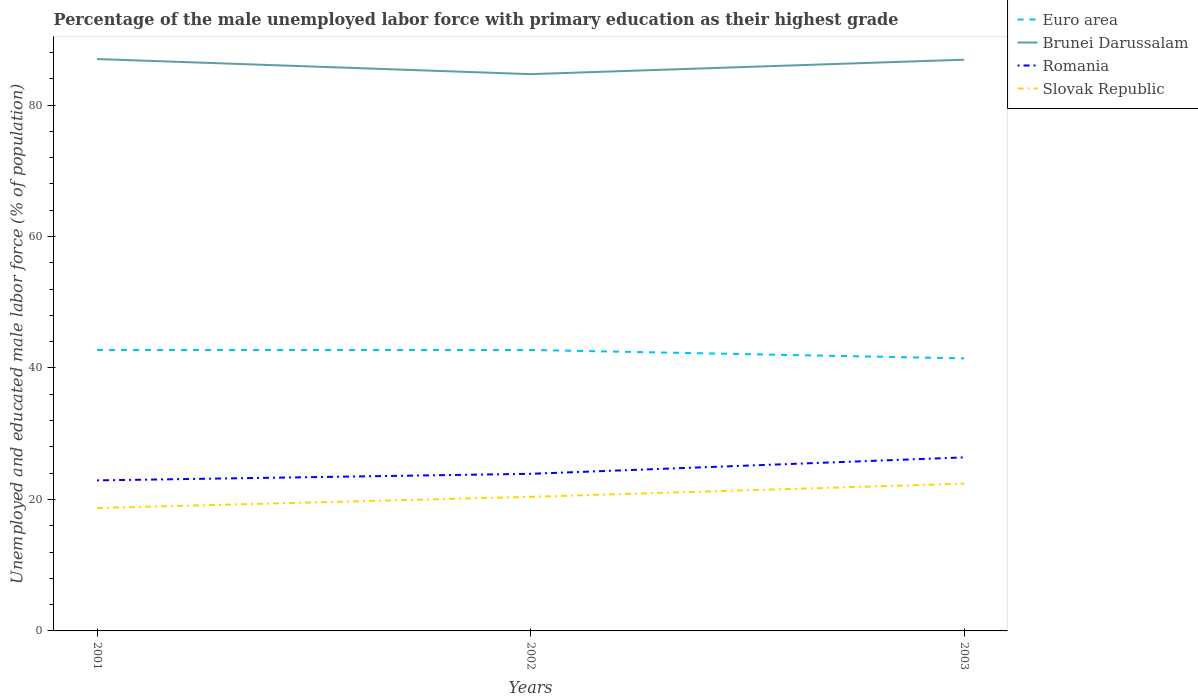Does the line corresponding to Slovak Republic intersect with the line corresponding to Euro area?
Provide a short and direct response. No. Is the number of lines equal to the number of legend labels?
Ensure brevity in your answer.  Yes. Across all years, what is the maximum percentage of the unemployed male labor force with primary education in Brunei Darussalam?
Your answer should be very brief. 84.7. How many lines are there?
Your answer should be very brief. 4. How many years are there in the graph?
Offer a very short reply. 3. What is the difference between two consecutive major ticks on the Y-axis?
Provide a succinct answer. 20. Where does the legend appear in the graph?
Offer a very short reply. Top right. How are the legend labels stacked?
Ensure brevity in your answer.  Vertical. What is the title of the graph?
Ensure brevity in your answer.  Percentage of the male unemployed labor force with primary education as their highest grade. What is the label or title of the Y-axis?
Provide a short and direct response. Unemployed and educated male labor force (% of population). What is the Unemployed and educated male labor force (% of population) in Euro area in 2001?
Offer a very short reply. 42.74. What is the Unemployed and educated male labor force (% of population) in Romania in 2001?
Offer a terse response. 22.9. What is the Unemployed and educated male labor force (% of population) of Slovak Republic in 2001?
Ensure brevity in your answer.  18.7. What is the Unemployed and educated male labor force (% of population) in Euro area in 2002?
Provide a short and direct response. 42.74. What is the Unemployed and educated male labor force (% of population) in Brunei Darussalam in 2002?
Your answer should be very brief. 84.7. What is the Unemployed and educated male labor force (% of population) in Romania in 2002?
Keep it short and to the point. 23.9. What is the Unemployed and educated male labor force (% of population) of Slovak Republic in 2002?
Your answer should be very brief. 20.4. What is the Unemployed and educated male labor force (% of population) of Euro area in 2003?
Your answer should be very brief. 41.46. What is the Unemployed and educated male labor force (% of population) of Brunei Darussalam in 2003?
Make the answer very short. 86.9. What is the Unemployed and educated male labor force (% of population) of Romania in 2003?
Offer a terse response. 26.4. What is the Unemployed and educated male labor force (% of population) in Slovak Republic in 2003?
Your response must be concise. 22.4. Across all years, what is the maximum Unemployed and educated male labor force (% of population) in Euro area?
Give a very brief answer. 42.74. Across all years, what is the maximum Unemployed and educated male labor force (% of population) in Romania?
Offer a terse response. 26.4. Across all years, what is the maximum Unemployed and educated male labor force (% of population) in Slovak Republic?
Your response must be concise. 22.4. Across all years, what is the minimum Unemployed and educated male labor force (% of population) in Euro area?
Ensure brevity in your answer.  41.46. Across all years, what is the minimum Unemployed and educated male labor force (% of population) in Brunei Darussalam?
Provide a succinct answer. 84.7. Across all years, what is the minimum Unemployed and educated male labor force (% of population) in Romania?
Offer a very short reply. 22.9. Across all years, what is the minimum Unemployed and educated male labor force (% of population) of Slovak Republic?
Make the answer very short. 18.7. What is the total Unemployed and educated male labor force (% of population) in Euro area in the graph?
Keep it short and to the point. 126.95. What is the total Unemployed and educated male labor force (% of population) of Brunei Darussalam in the graph?
Your response must be concise. 258.6. What is the total Unemployed and educated male labor force (% of population) of Romania in the graph?
Your answer should be very brief. 73.2. What is the total Unemployed and educated male labor force (% of population) in Slovak Republic in the graph?
Your answer should be compact. 61.5. What is the difference between the Unemployed and educated male labor force (% of population) in Euro area in 2001 and that in 2002?
Provide a succinct answer. 0. What is the difference between the Unemployed and educated male labor force (% of population) in Romania in 2001 and that in 2002?
Provide a short and direct response. -1. What is the difference between the Unemployed and educated male labor force (% of population) of Euro area in 2001 and that in 2003?
Your answer should be very brief. 1.28. What is the difference between the Unemployed and educated male labor force (% of population) in Slovak Republic in 2001 and that in 2003?
Provide a succinct answer. -3.7. What is the difference between the Unemployed and educated male labor force (% of population) of Euro area in 2002 and that in 2003?
Ensure brevity in your answer.  1.28. What is the difference between the Unemployed and educated male labor force (% of population) in Brunei Darussalam in 2002 and that in 2003?
Your answer should be compact. -2.2. What is the difference between the Unemployed and educated male labor force (% of population) in Romania in 2002 and that in 2003?
Provide a short and direct response. -2.5. What is the difference between the Unemployed and educated male labor force (% of population) of Slovak Republic in 2002 and that in 2003?
Your answer should be compact. -2. What is the difference between the Unemployed and educated male labor force (% of population) in Euro area in 2001 and the Unemployed and educated male labor force (% of population) in Brunei Darussalam in 2002?
Offer a terse response. -41.96. What is the difference between the Unemployed and educated male labor force (% of population) in Euro area in 2001 and the Unemployed and educated male labor force (% of population) in Romania in 2002?
Offer a very short reply. 18.84. What is the difference between the Unemployed and educated male labor force (% of population) of Euro area in 2001 and the Unemployed and educated male labor force (% of population) of Slovak Republic in 2002?
Give a very brief answer. 22.34. What is the difference between the Unemployed and educated male labor force (% of population) in Brunei Darussalam in 2001 and the Unemployed and educated male labor force (% of population) in Romania in 2002?
Make the answer very short. 63.1. What is the difference between the Unemployed and educated male labor force (% of population) of Brunei Darussalam in 2001 and the Unemployed and educated male labor force (% of population) of Slovak Republic in 2002?
Make the answer very short. 66.6. What is the difference between the Unemployed and educated male labor force (% of population) in Euro area in 2001 and the Unemployed and educated male labor force (% of population) in Brunei Darussalam in 2003?
Make the answer very short. -44.16. What is the difference between the Unemployed and educated male labor force (% of population) of Euro area in 2001 and the Unemployed and educated male labor force (% of population) of Romania in 2003?
Give a very brief answer. 16.34. What is the difference between the Unemployed and educated male labor force (% of population) in Euro area in 2001 and the Unemployed and educated male labor force (% of population) in Slovak Republic in 2003?
Give a very brief answer. 20.34. What is the difference between the Unemployed and educated male labor force (% of population) in Brunei Darussalam in 2001 and the Unemployed and educated male labor force (% of population) in Romania in 2003?
Make the answer very short. 60.6. What is the difference between the Unemployed and educated male labor force (% of population) of Brunei Darussalam in 2001 and the Unemployed and educated male labor force (% of population) of Slovak Republic in 2003?
Your answer should be compact. 64.6. What is the difference between the Unemployed and educated male labor force (% of population) of Euro area in 2002 and the Unemployed and educated male labor force (% of population) of Brunei Darussalam in 2003?
Offer a terse response. -44.16. What is the difference between the Unemployed and educated male labor force (% of population) in Euro area in 2002 and the Unemployed and educated male labor force (% of population) in Romania in 2003?
Offer a very short reply. 16.34. What is the difference between the Unemployed and educated male labor force (% of population) in Euro area in 2002 and the Unemployed and educated male labor force (% of population) in Slovak Republic in 2003?
Ensure brevity in your answer.  20.34. What is the difference between the Unemployed and educated male labor force (% of population) in Brunei Darussalam in 2002 and the Unemployed and educated male labor force (% of population) in Romania in 2003?
Ensure brevity in your answer.  58.3. What is the difference between the Unemployed and educated male labor force (% of population) of Brunei Darussalam in 2002 and the Unemployed and educated male labor force (% of population) of Slovak Republic in 2003?
Offer a very short reply. 62.3. What is the average Unemployed and educated male labor force (% of population) of Euro area per year?
Keep it short and to the point. 42.32. What is the average Unemployed and educated male labor force (% of population) of Brunei Darussalam per year?
Provide a succinct answer. 86.2. What is the average Unemployed and educated male labor force (% of population) in Romania per year?
Your answer should be compact. 24.4. In the year 2001, what is the difference between the Unemployed and educated male labor force (% of population) of Euro area and Unemployed and educated male labor force (% of population) of Brunei Darussalam?
Keep it short and to the point. -44.26. In the year 2001, what is the difference between the Unemployed and educated male labor force (% of population) in Euro area and Unemployed and educated male labor force (% of population) in Romania?
Your response must be concise. 19.84. In the year 2001, what is the difference between the Unemployed and educated male labor force (% of population) of Euro area and Unemployed and educated male labor force (% of population) of Slovak Republic?
Keep it short and to the point. 24.04. In the year 2001, what is the difference between the Unemployed and educated male labor force (% of population) in Brunei Darussalam and Unemployed and educated male labor force (% of population) in Romania?
Offer a terse response. 64.1. In the year 2001, what is the difference between the Unemployed and educated male labor force (% of population) in Brunei Darussalam and Unemployed and educated male labor force (% of population) in Slovak Republic?
Make the answer very short. 68.3. In the year 2002, what is the difference between the Unemployed and educated male labor force (% of population) of Euro area and Unemployed and educated male labor force (% of population) of Brunei Darussalam?
Your response must be concise. -41.96. In the year 2002, what is the difference between the Unemployed and educated male labor force (% of population) of Euro area and Unemployed and educated male labor force (% of population) of Romania?
Offer a very short reply. 18.84. In the year 2002, what is the difference between the Unemployed and educated male labor force (% of population) of Euro area and Unemployed and educated male labor force (% of population) of Slovak Republic?
Offer a very short reply. 22.34. In the year 2002, what is the difference between the Unemployed and educated male labor force (% of population) in Brunei Darussalam and Unemployed and educated male labor force (% of population) in Romania?
Give a very brief answer. 60.8. In the year 2002, what is the difference between the Unemployed and educated male labor force (% of population) of Brunei Darussalam and Unemployed and educated male labor force (% of population) of Slovak Republic?
Offer a terse response. 64.3. In the year 2002, what is the difference between the Unemployed and educated male labor force (% of population) of Romania and Unemployed and educated male labor force (% of population) of Slovak Republic?
Provide a succinct answer. 3.5. In the year 2003, what is the difference between the Unemployed and educated male labor force (% of population) of Euro area and Unemployed and educated male labor force (% of population) of Brunei Darussalam?
Ensure brevity in your answer.  -45.44. In the year 2003, what is the difference between the Unemployed and educated male labor force (% of population) in Euro area and Unemployed and educated male labor force (% of population) in Romania?
Your response must be concise. 15.06. In the year 2003, what is the difference between the Unemployed and educated male labor force (% of population) of Euro area and Unemployed and educated male labor force (% of population) of Slovak Republic?
Ensure brevity in your answer.  19.06. In the year 2003, what is the difference between the Unemployed and educated male labor force (% of population) of Brunei Darussalam and Unemployed and educated male labor force (% of population) of Romania?
Your answer should be compact. 60.5. In the year 2003, what is the difference between the Unemployed and educated male labor force (% of population) in Brunei Darussalam and Unemployed and educated male labor force (% of population) in Slovak Republic?
Your response must be concise. 64.5. In the year 2003, what is the difference between the Unemployed and educated male labor force (% of population) in Romania and Unemployed and educated male labor force (% of population) in Slovak Republic?
Make the answer very short. 4. What is the ratio of the Unemployed and educated male labor force (% of population) in Euro area in 2001 to that in 2002?
Ensure brevity in your answer.  1. What is the ratio of the Unemployed and educated male labor force (% of population) in Brunei Darussalam in 2001 to that in 2002?
Give a very brief answer. 1.03. What is the ratio of the Unemployed and educated male labor force (% of population) of Romania in 2001 to that in 2002?
Your answer should be compact. 0.96. What is the ratio of the Unemployed and educated male labor force (% of population) in Slovak Republic in 2001 to that in 2002?
Your answer should be compact. 0.92. What is the ratio of the Unemployed and educated male labor force (% of population) in Euro area in 2001 to that in 2003?
Make the answer very short. 1.03. What is the ratio of the Unemployed and educated male labor force (% of population) of Brunei Darussalam in 2001 to that in 2003?
Your answer should be compact. 1. What is the ratio of the Unemployed and educated male labor force (% of population) in Romania in 2001 to that in 2003?
Ensure brevity in your answer.  0.87. What is the ratio of the Unemployed and educated male labor force (% of population) of Slovak Republic in 2001 to that in 2003?
Offer a terse response. 0.83. What is the ratio of the Unemployed and educated male labor force (% of population) in Euro area in 2002 to that in 2003?
Your answer should be very brief. 1.03. What is the ratio of the Unemployed and educated male labor force (% of population) in Brunei Darussalam in 2002 to that in 2003?
Give a very brief answer. 0.97. What is the ratio of the Unemployed and educated male labor force (% of population) in Romania in 2002 to that in 2003?
Your answer should be compact. 0.91. What is the ratio of the Unemployed and educated male labor force (% of population) of Slovak Republic in 2002 to that in 2003?
Make the answer very short. 0.91. What is the difference between the highest and the second highest Unemployed and educated male labor force (% of population) of Euro area?
Offer a terse response. 0. What is the difference between the highest and the second highest Unemployed and educated male labor force (% of population) in Romania?
Provide a succinct answer. 2.5. What is the difference between the highest and the second highest Unemployed and educated male labor force (% of population) in Slovak Republic?
Make the answer very short. 2. What is the difference between the highest and the lowest Unemployed and educated male labor force (% of population) of Euro area?
Make the answer very short. 1.28. What is the difference between the highest and the lowest Unemployed and educated male labor force (% of population) of Brunei Darussalam?
Your response must be concise. 2.3. What is the difference between the highest and the lowest Unemployed and educated male labor force (% of population) in Romania?
Your answer should be compact. 3.5. 